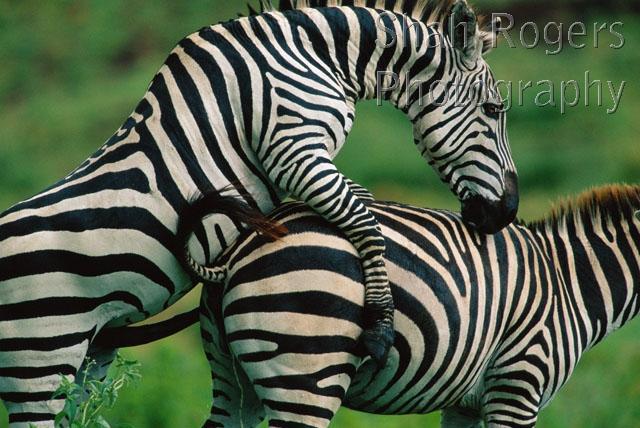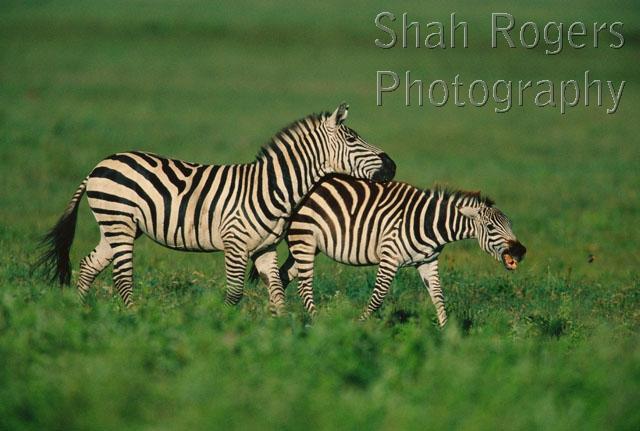The first image is the image on the left, the second image is the image on the right. For the images displayed, is the sentence "In one image there are two zebras walking in the same direction." factually correct? Answer yes or no. Yes. The first image is the image on the left, the second image is the image on the right. Examine the images to the left and right. Is the description "An image shows two zebras standing close together with their heads facing in opposite directions." accurate? Answer yes or no. No. 